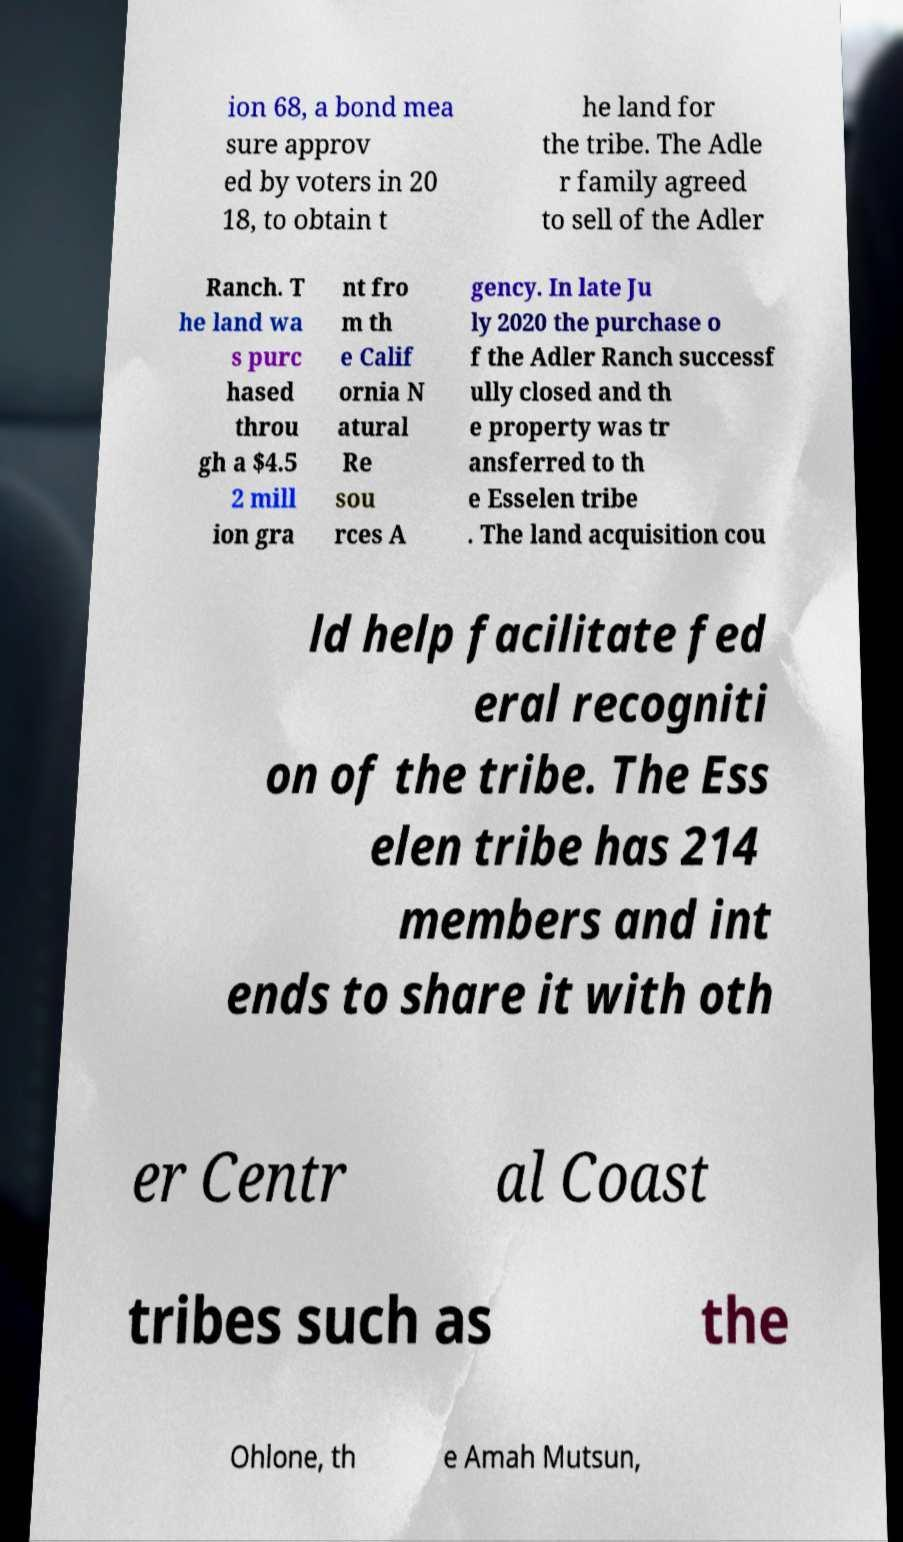Please read and relay the text visible in this image. What does it say? ion 68, a bond mea sure approv ed by voters in 20 18, to obtain t he land for the tribe. The Adle r family agreed to sell of the Adler Ranch. T he land wa s purc hased throu gh a $4.5 2 mill ion gra nt fro m th e Calif ornia N atural Re sou rces A gency. In late Ju ly 2020 the purchase o f the Adler Ranch successf ully closed and th e property was tr ansferred to th e Esselen tribe . The land acquisition cou ld help facilitate fed eral recogniti on of the tribe. The Ess elen tribe has 214 members and int ends to share it with oth er Centr al Coast tribes such as the Ohlone, th e Amah Mutsun, 